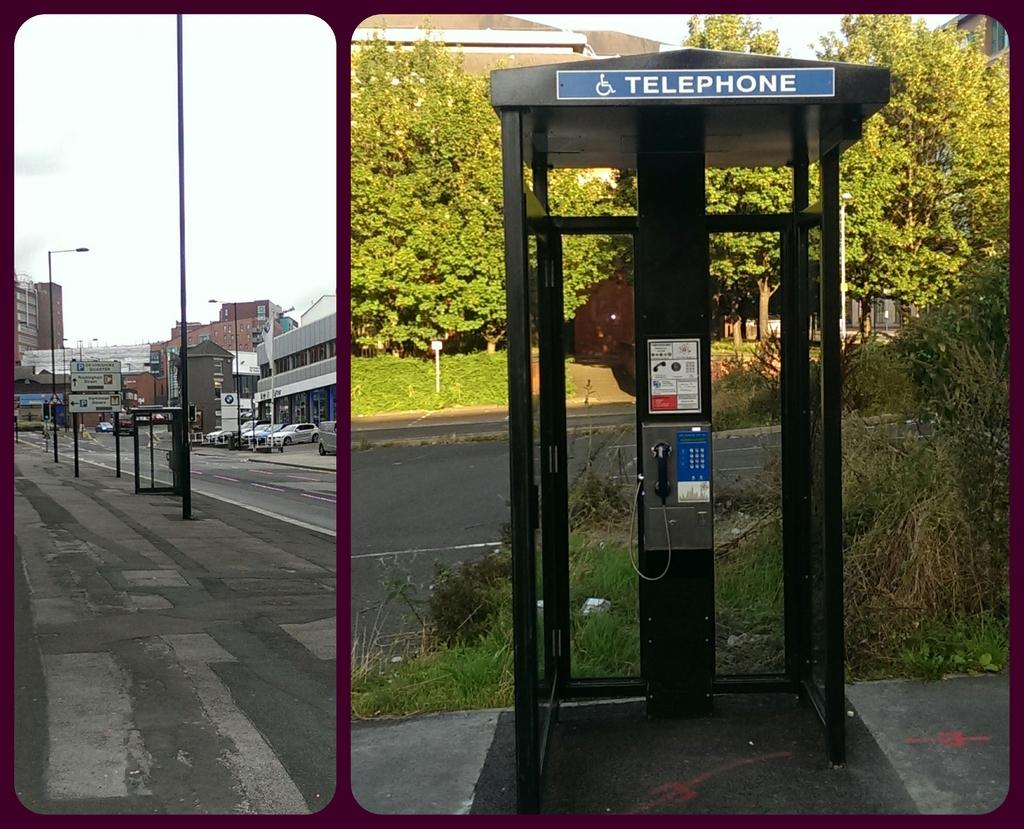<image>
Give a short and clear explanation of the subsequent image. A telephone booth next to a street surrounded by trees. 